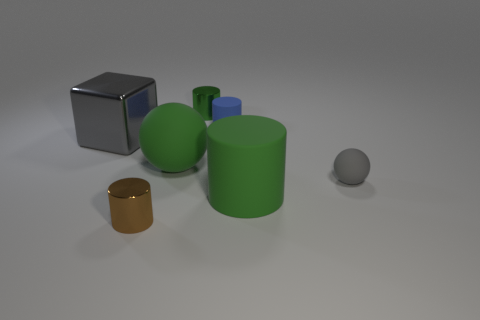Subtract 1 cylinders. How many cylinders are left? 3 Add 2 purple objects. How many objects exist? 9 Subtract all cylinders. How many objects are left? 3 Add 3 big metallic cubes. How many big metallic cubes exist? 4 Subtract 0 red spheres. How many objects are left? 7 Subtract all large purple cylinders. Subtract all big green cylinders. How many objects are left? 6 Add 5 large green things. How many large green things are left? 7 